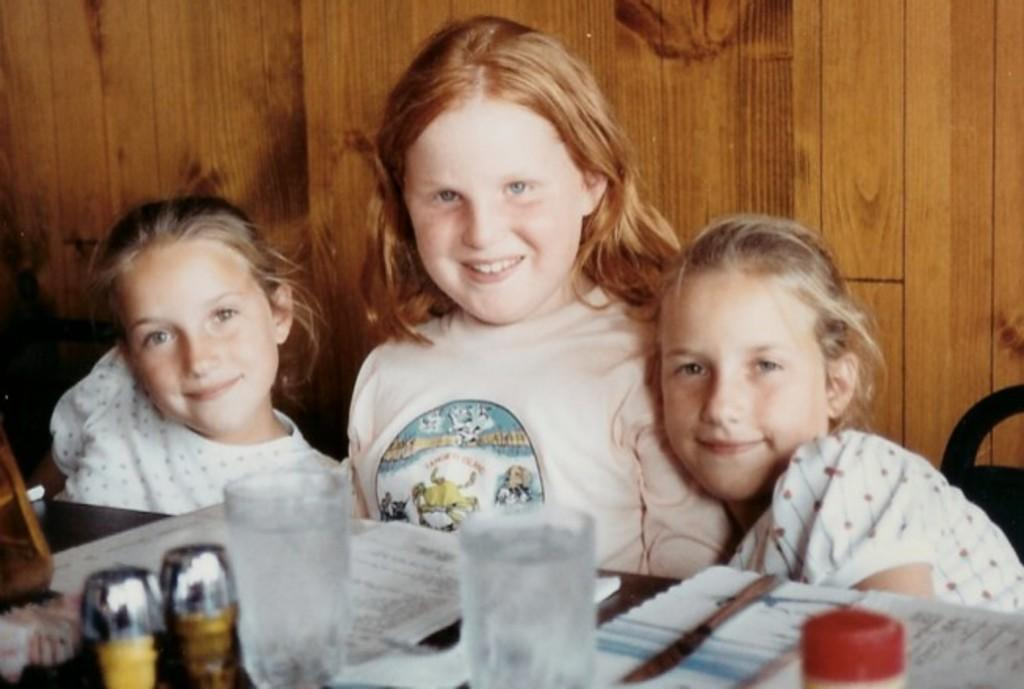How many people are sitting in the image? There are three persons sitting in the image. What objects are on the table in the image? There are glasses, papers, and bottles on the table in the image. What can be seen in the background of the image? The background of the image includes a wooden wall. Where are the beds located in the image? There are no beds present in the image. What type of locket can be seen around the neck of one of the persons in the image? There is no locket visible around the neck of any person in the image. 